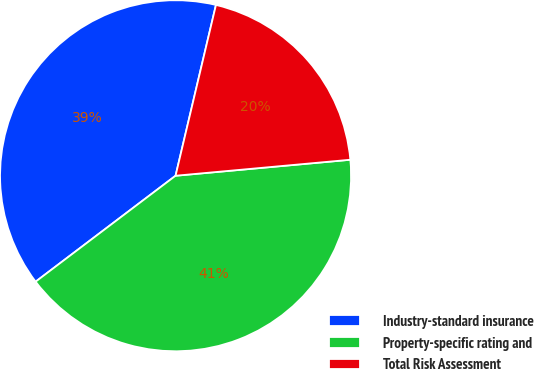Convert chart to OTSL. <chart><loc_0><loc_0><loc_500><loc_500><pie_chart><fcel>Industry-standard insurance<fcel>Property-specific rating and<fcel>Total Risk Assessment<nl><fcel>39.01%<fcel>41.14%<fcel>19.85%<nl></chart> 